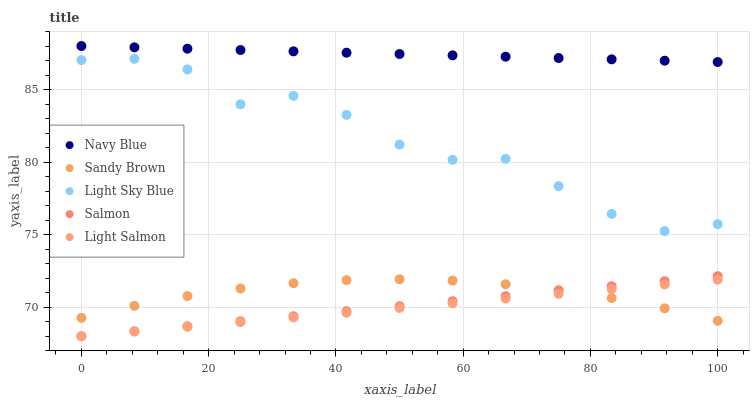Does Light Salmon have the minimum area under the curve?
Answer yes or no. Yes. Does Navy Blue have the maximum area under the curve?
Answer yes or no. Yes. Does Light Sky Blue have the minimum area under the curve?
Answer yes or no. No. Does Light Sky Blue have the maximum area under the curve?
Answer yes or no. No. Is Light Salmon the smoothest?
Answer yes or no. Yes. Is Light Sky Blue the roughest?
Answer yes or no. Yes. Is Light Sky Blue the smoothest?
Answer yes or no. No. Is Light Salmon the roughest?
Answer yes or no. No. Does Light Salmon have the lowest value?
Answer yes or no. Yes. Does Light Sky Blue have the lowest value?
Answer yes or no. No. Does Navy Blue have the highest value?
Answer yes or no. Yes. Does Light Sky Blue have the highest value?
Answer yes or no. No. Is Sandy Brown less than Navy Blue?
Answer yes or no. Yes. Is Light Sky Blue greater than Salmon?
Answer yes or no. Yes. Does Sandy Brown intersect Salmon?
Answer yes or no. Yes. Is Sandy Brown less than Salmon?
Answer yes or no. No. Is Sandy Brown greater than Salmon?
Answer yes or no. No. Does Sandy Brown intersect Navy Blue?
Answer yes or no. No. 